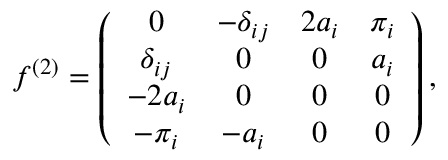<formula> <loc_0><loc_0><loc_500><loc_500>f ^ { ( 2 ) } = \left ( \begin{array} { c c c c } { 0 } & { { - \delta _ { i j } } } & { { 2 a _ { i } } } & { { \pi _ { i } } } \\ { { \delta _ { i j } } } & { 0 } & { 0 } & { { a _ { i } } } \\ { { - 2 a _ { i } } } & { 0 } & { 0 } & { 0 } \\ { { - \pi _ { i } } } & { { - a _ { i } } } & { 0 } & { 0 } \end{array} \right ) ,</formula> 